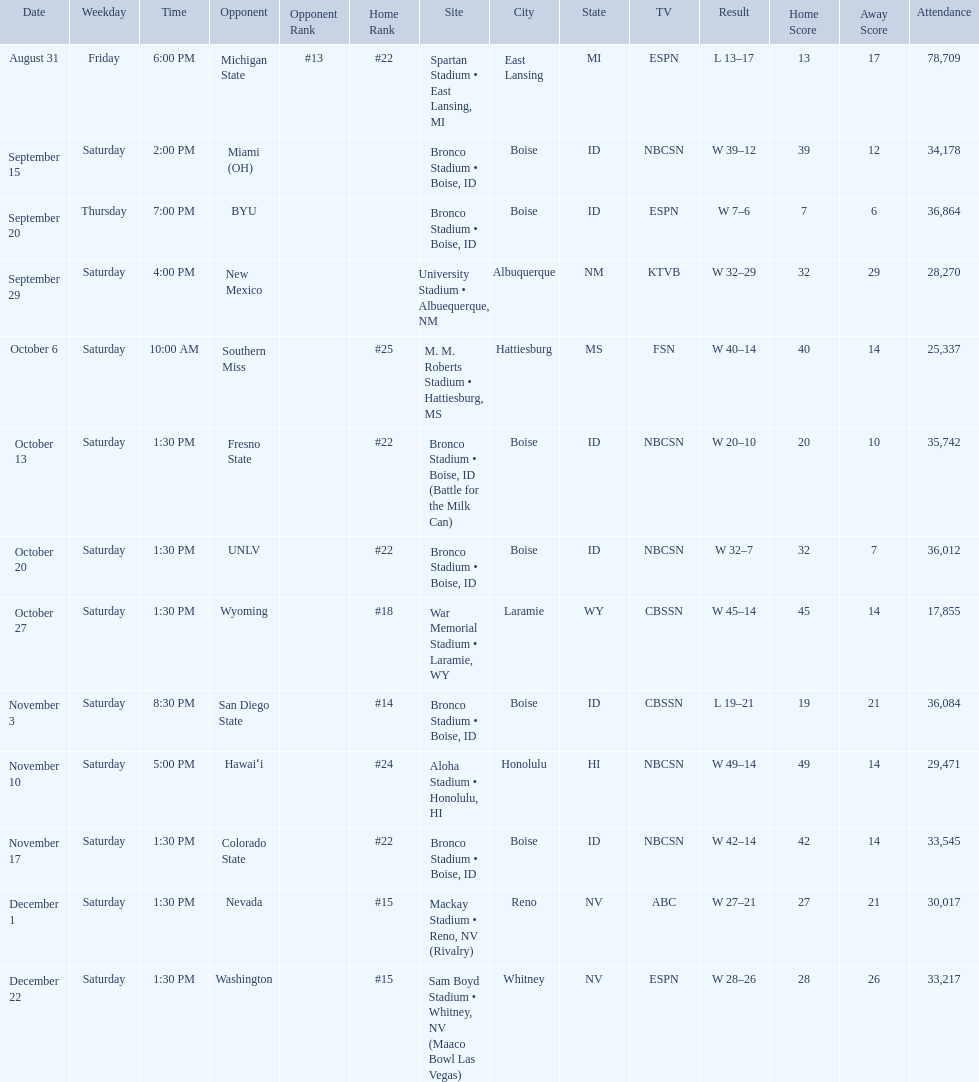What are all of the rankings? #22, , , , #25, #22, #22, #18, #14, #24, #22, #15, #15. Which of them was the best position? #14. 